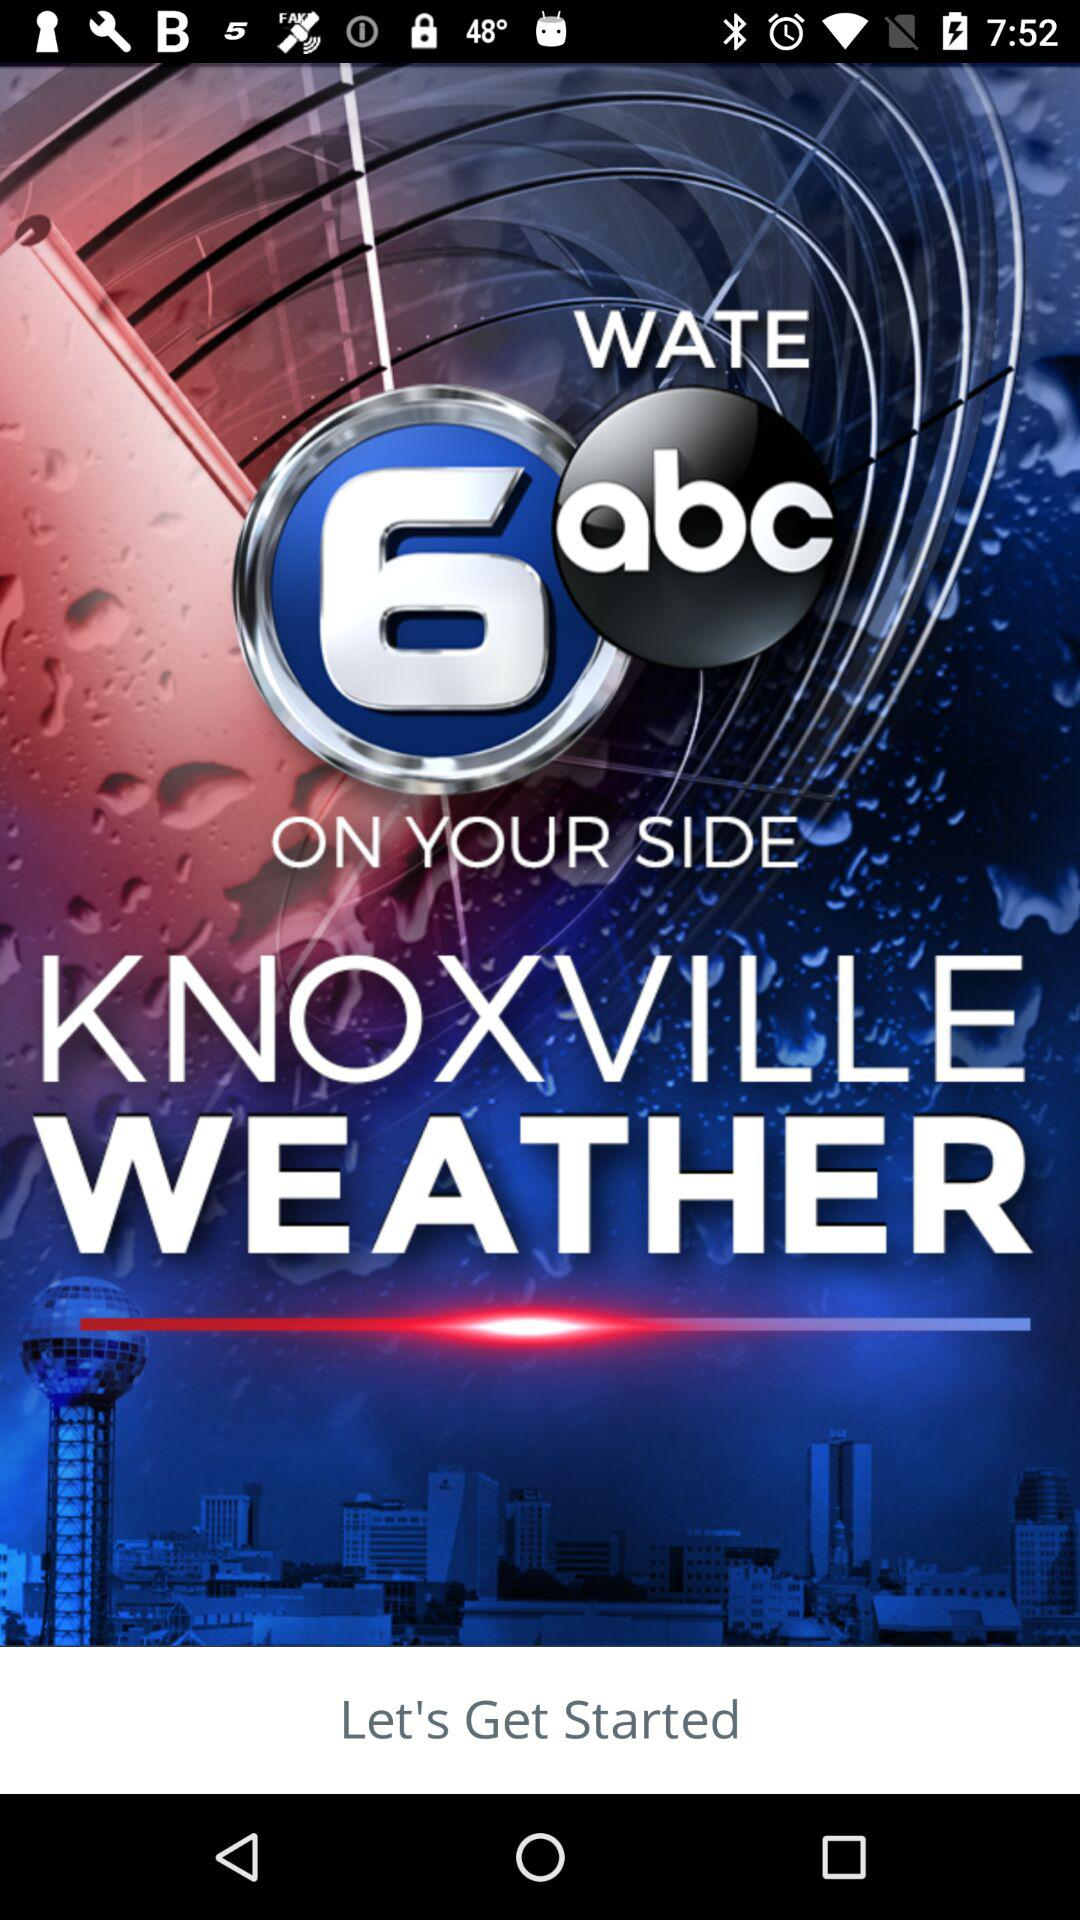What is the name of the application? The name of the application is "KNOXVILLE WEATHER". 